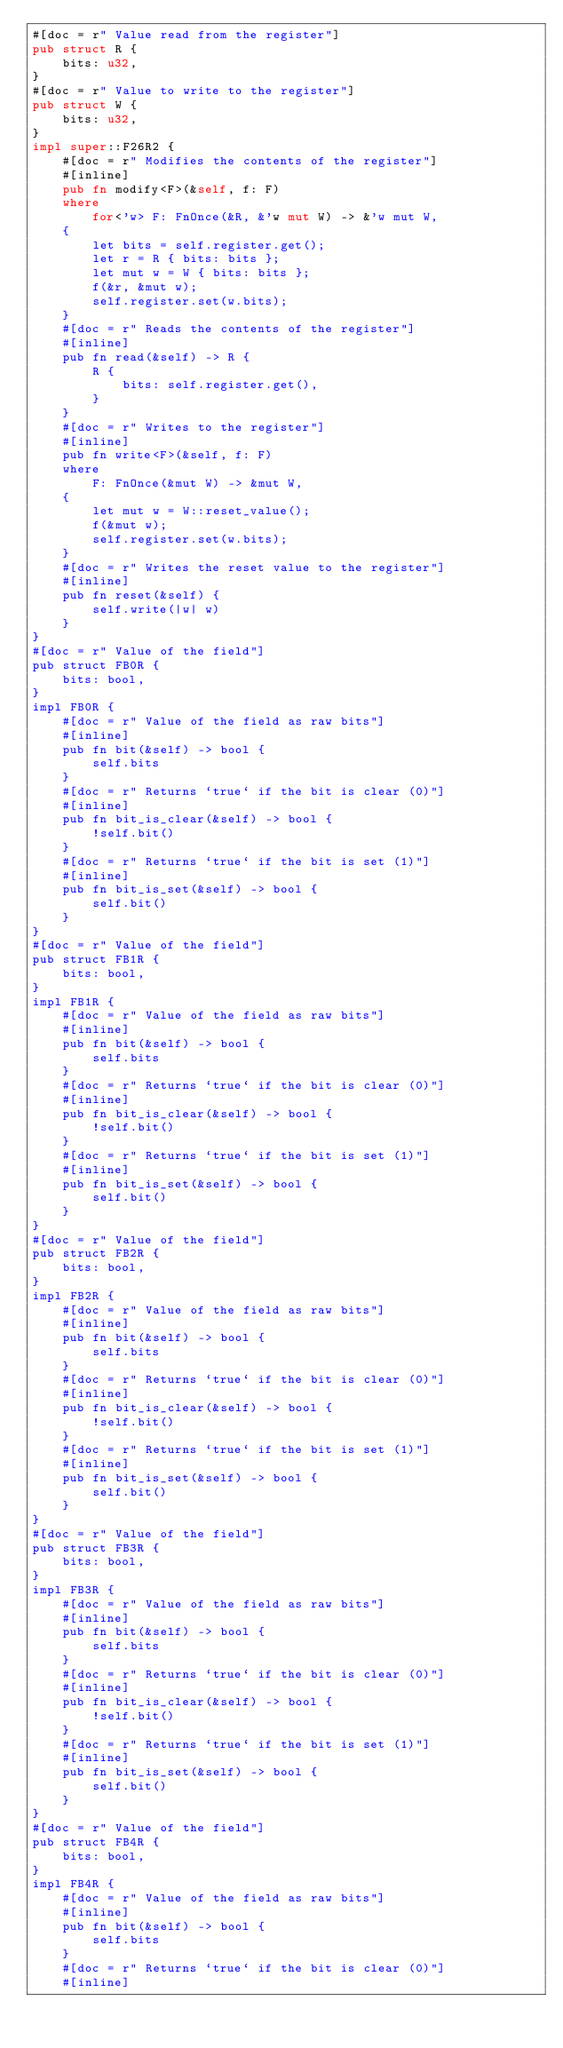<code> <loc_0><loc_0><loc_500><loc_500><_Rust_>#[doc = r" Value read from the register"]
pub struct R {
    bits: u32,
}
#[doc = r" Value to write to the register"]
pub struct W {
    bits: u32,
}
impl super::F26R2 {
    #[doc = r" Modifies the contents of the register"]
    #[inline]
    pub fn modify<F>(&self, f: F)
    where
        for<'w> F: FnOnce(&R, &'w mut W) -> &'w mut W,
    {
        let bits = self.register.get();
        let r = R { bits: bits };
        let mut w = W { bits: bits };
        f(&r, &mut w);
        self.register.set(w.bits);
    }
    #[doc = r" Reads the contents of the register"]
    #[inline]
    pub fn read(&self) -> R {
        R {
            bits: self.register.get(),
        }
    }
    #[doc = r" Writes to the register"]
    #[inline]
    pub fn write<F>(&self, f: F)
    where
        F: FnOnce(&mut W) -> &mut W,
    {
        let mut w = W::reset_value();
        f(&mut w);
        self.register.set(w.bits);
    }
    #[doc = r" Writes the reset value to the register"]
    #[inline]
    pub fn reset(&self) {
        self.write(|w| w)
    }
}
#[doc = r" Value of the field"]
pub struct FB0R {
    bits: bool,
}
impl FB0R {
    #[doc = r" Value of the field as raw bits"]
    #[inline]
    pub fn bit(&self) -> bool {
        self.bits
    }
    #[doc = r" Returns `true` if the bit is clear (0)"]
    #[inline]
    pub fn bit_is_clear(&self) -> bool {
        !self.bit()
    }
    #[doc = r" Returns `true` if the bit is set (1)"]
    #[inline]
    pub fn bit_is_set(&self) -> bool {
        self.bit()
    }
}
#[doc = r" Value of the field"]
pub struct FB1R {
    bits: bool,
}
impl FB1R {
    #[doc = r" Value of the field as raw bits"]
    #[inline]
    pub fn bit(&self) -> bool {
        self.bits
    }
    #[doc = r" Returns `true` if the bit is clear (0)"]
    #[inline]
    pub fn bit_is_clear(&self) -> bool {
        !self.bit()
    }
    #[doc = r" Returns `true` if the bit is set (1)"]
    #[inline]
    pub fn bit_is_set(&self) -> bool {
        self.bit()
    }
}
#[doc = r" Value of the field"]
pub struct FB2R {
    bits: bool,
}
impl FB2R {
    #[doc = r" Value of the field as raw bits"]
    #[inline]
    pub fn bit(&self) -> bool {
        self.bits
    }
    #[doc = r" Returns `true` if the bit is clear (0)"]
    #[inline]
    pub fn bit_is_clear(&self) -> bool {
        !self.bit()
    }
    #[doc = r" Returns `true` if the bit is set (1)"]
    #[inline]
    pub fn bit_is_set(&self) -> bool {
        self.bit()
    }
}
#[doc = r" Value of the field"]
pub struct FB3R {
    bits: bool,
}
impl FB3R {
    #[doc = r" Value of the field as raw bits"]
    #[inline]
    pub fn bit(&self) -> bool {
        self.bits
    }
    #[doc = r" Returns `true` if the bit is clear (0)"]
    #[inline]
    pub fn bit_is_clear(&self) -> bool {
        !self.bit()
    }
    #[doc = r" Returns `true` if the bit is set (1)"]
    #[inline]
    pub fn bit_is_set(&self) -> bool {
        self.bit()
    }
}
#[doc = r" Value of the field"]
pub struct FB4R {
    bits: bool,
}
impl FB4R {
    #[doc = r" Value of the field as raw bits"]
    #[inline]
    pub fn bit(&self) -> bool {
        self.bits
    }
    #[doc = r" Returns `true` if the bit is clear (0)"]
    #[inline]</code> 